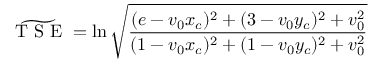Convert formula to latex. <formula><loc_0><loc_0><loc_500><loc_500>\widetilde { T S E } = \ln \sqrt { \frac { ( e - v _ { 0 } x _ { c } ) ^ { 2 } + ( 3 - v _ { 0 } y _ { c } ) ^ { 2 } + v _ { 0 } ^ { 2 } } { ( 1 - v _ { 0 } x _ { c } ) ^ { 2 } + ( 1 - v _ { 0 } y _ { c } ) ^ { 2 } + v _ { 0 } ^ { 2 } } }</formula> 